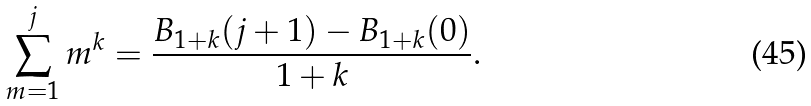<formula> <loc_0><loc_0><loc_500><loc_500>\sum _ { m = 1 } ^ { j } m ^ { k } = \frac { B _ { 1 + k } ( j + 1 ) - B _ { 1 + k } ( 0 ) } { 1 + k } .</formula> 